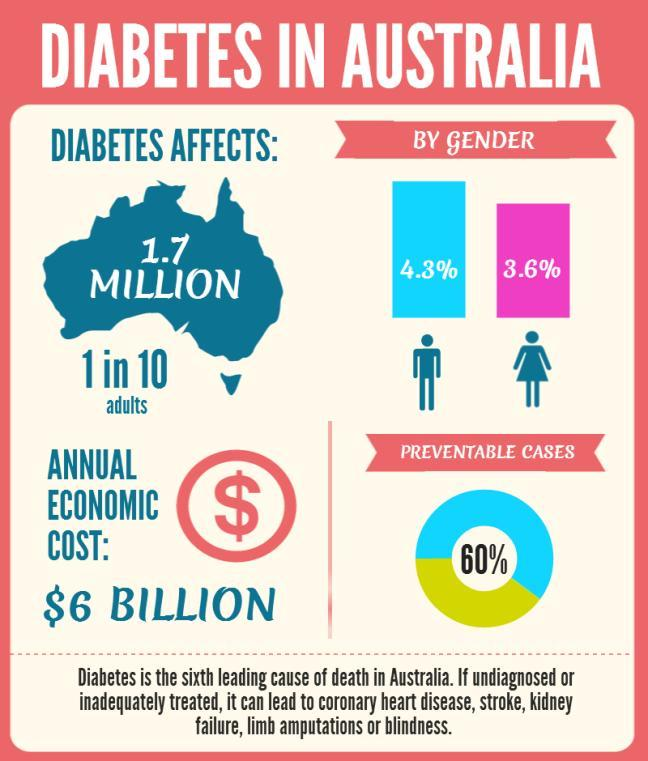what could lead to kidney failure
Answer the question with a short phrase. diabetes How many females are affected by diabetes 3.6% what could lead to blindness or stroke diabetes What percentage of cases can be prevented 60 